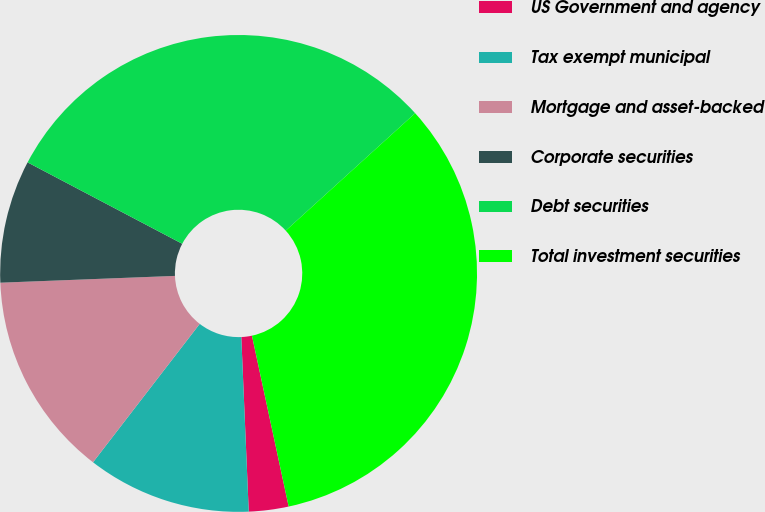Convert chart. <chart><loc_0><loc_0><loc_500><loc_500><pie_chart><fcel>US Government and agency<fcel>Tax exempt municipal<fcel>Mortgage and asset-backed<fcel>Corporate securities<fcel>Debt securities<fcel>Total investment securities<nl><fcel>2.69%<fcel>11.13%<fcel>13.93%<fcel>8.33%<fcel>30.56%<fcel>33.36%<nl></chart> 